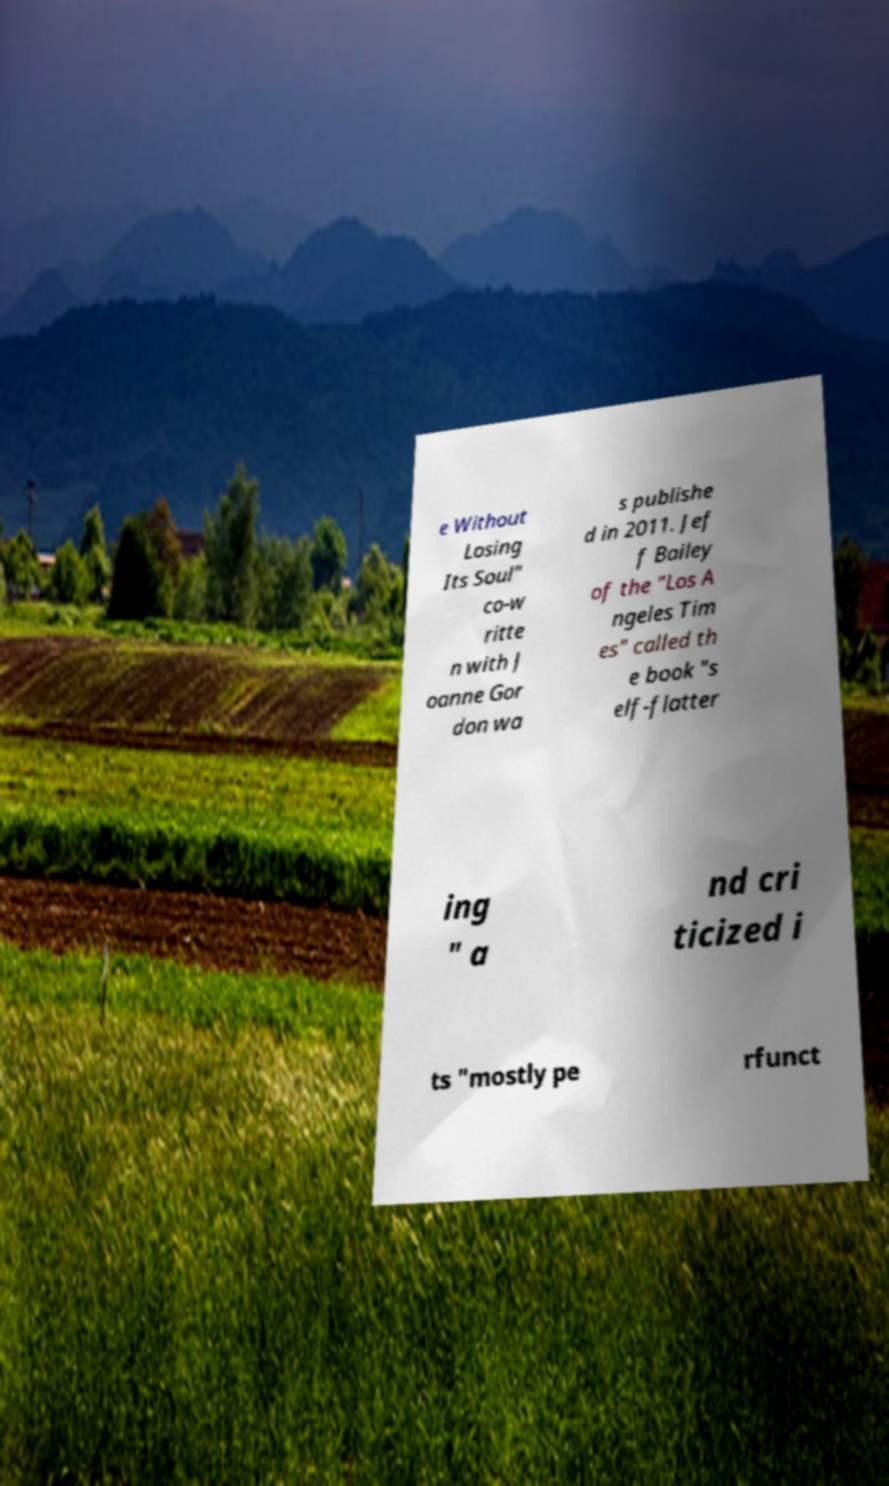Could you extract and type out the text from this image? e Without Losing Its Soul" co-w ritte n with J oanne Gor don wa s publishe d in 2011. Jef f Bailey of the "Los A ngeles Tim es" called th e book "s elf-flatter ing " a nd cri ticized i ts "mostly pe rfunct 